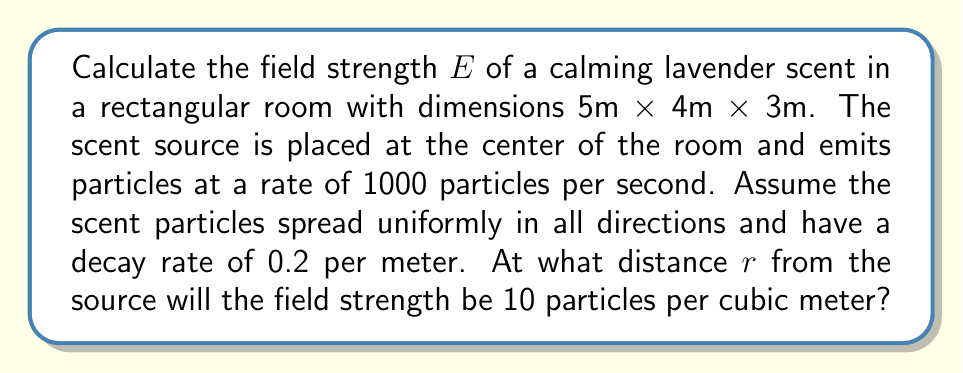Can you solve this math problem? 1. The field strength $E$ of the lavender scent can be modeled using the inverse square law and an exponential decay factor:

   $$E(r) = \frac{k}{4\pi r^2} e^{-\alpha r}$$

   where $k$ is the source strength, $r$ is the distance from the source, and $\alpha$ is the decay rate.

2. Given:
   - Source strength $k = 1000$ particles/s
   - Decay rate $\alpha = 0.2$ m^(-1)
   - Desired field strength $E = 10$ particles/m^3

3. Substitute the values into the equation:

   $$10 = \frac{1000}{4\pi r^2} e^{-0.2r}$$

4. Multiply both sides by $4\pi r^2$:

   $$40\pi r^2 = 1000 e^{-0.2r}$$

5. Take the natural logarithm of both sides:

   $$\ln(40\pi r^2) = \ln(1000) - 0.2r$$

6. Expand the left side:

   $$\ln(40\pi) + 2\ln(r) = \ln(1000) - 0.2r$$

7. This equation cannot be solved analytically. We need to use numerical methods like Newton-Raphson or graphical methods to find the solution.

8. Using a numerical solver, we find that $r \approx 1.54$ m.

9. Verify that this solution creates a calm environment by checking if it's within the room's boundaries:
   The room's diagonal is $\sqrt{5^2 + 4^2 + 3^2} \approx 7.07$ m, so the solution is valid.
Answer: $r \approx 1.54$ m 